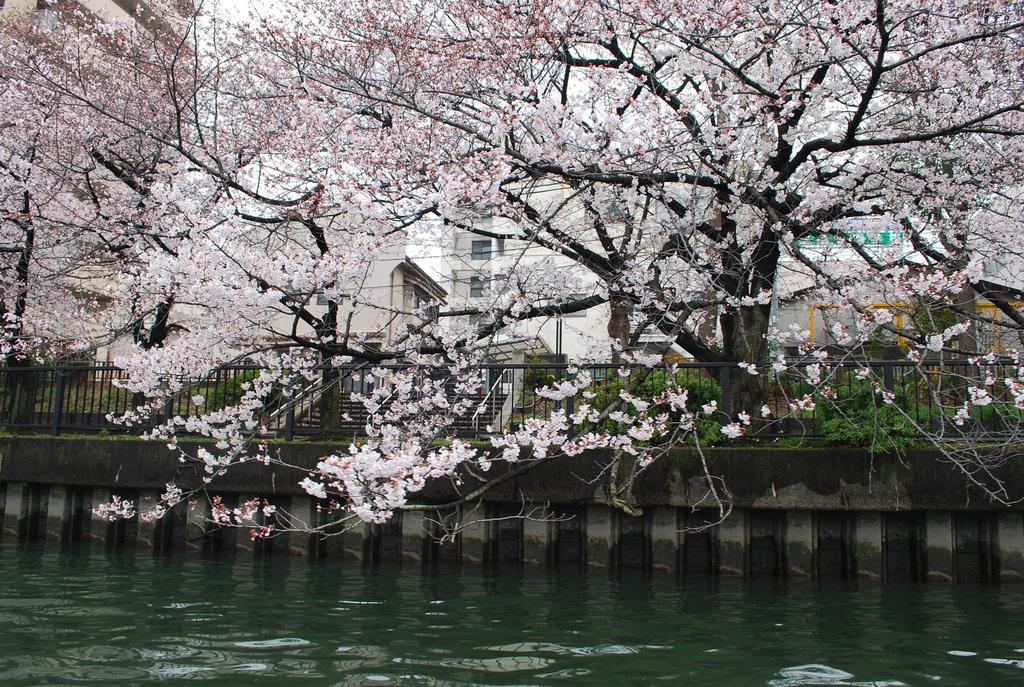Please provide a concise description of this image. Front we can see water. Background there are buildings with windows, steps and trees. 